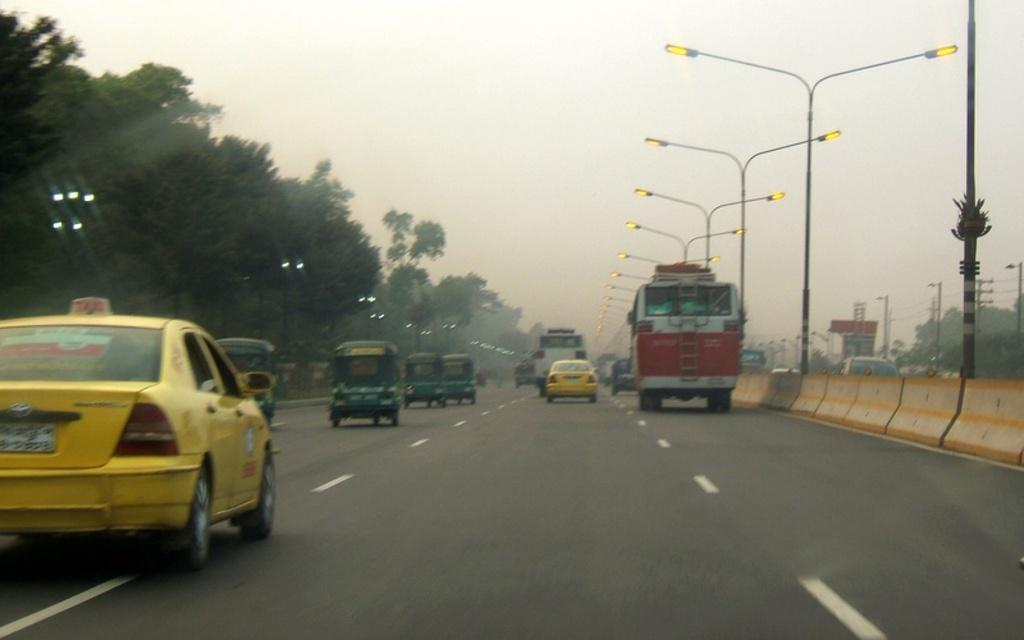What can be seen on the road in the image? There is a group of vehicles on the road in the image. What type of structures are visible along the road? Street poles are visible in the image. What type of vegetation is present in the image? There is a group of trees in the image. What object is present in the image that might be used for displaying information or advertisements? A board is present in the image. What type of structures are visible in the image besides street poles? Poles are visible in the image. What part of the natural environment is visible in the image? The sky is visible in the image. Can you see any mice running around in the image? There are no mice present in the image. Is there a battle taking place in the image? There is no battle depicted in the image. 